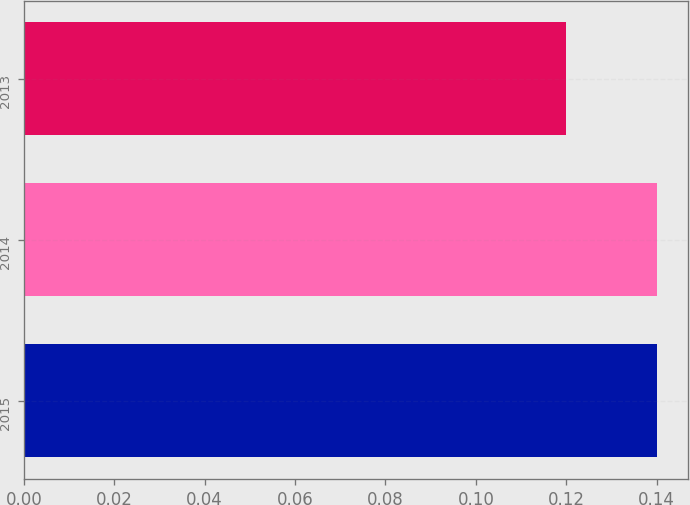Convert chart. <chart><loc_0><loc_0><loc_500><loc_500><bar_chart><fcel>2015<fcel>2014<fcel>2013<nl><fcel>0.14<fcel>0.14<fcel>0.12<nl></chart> 